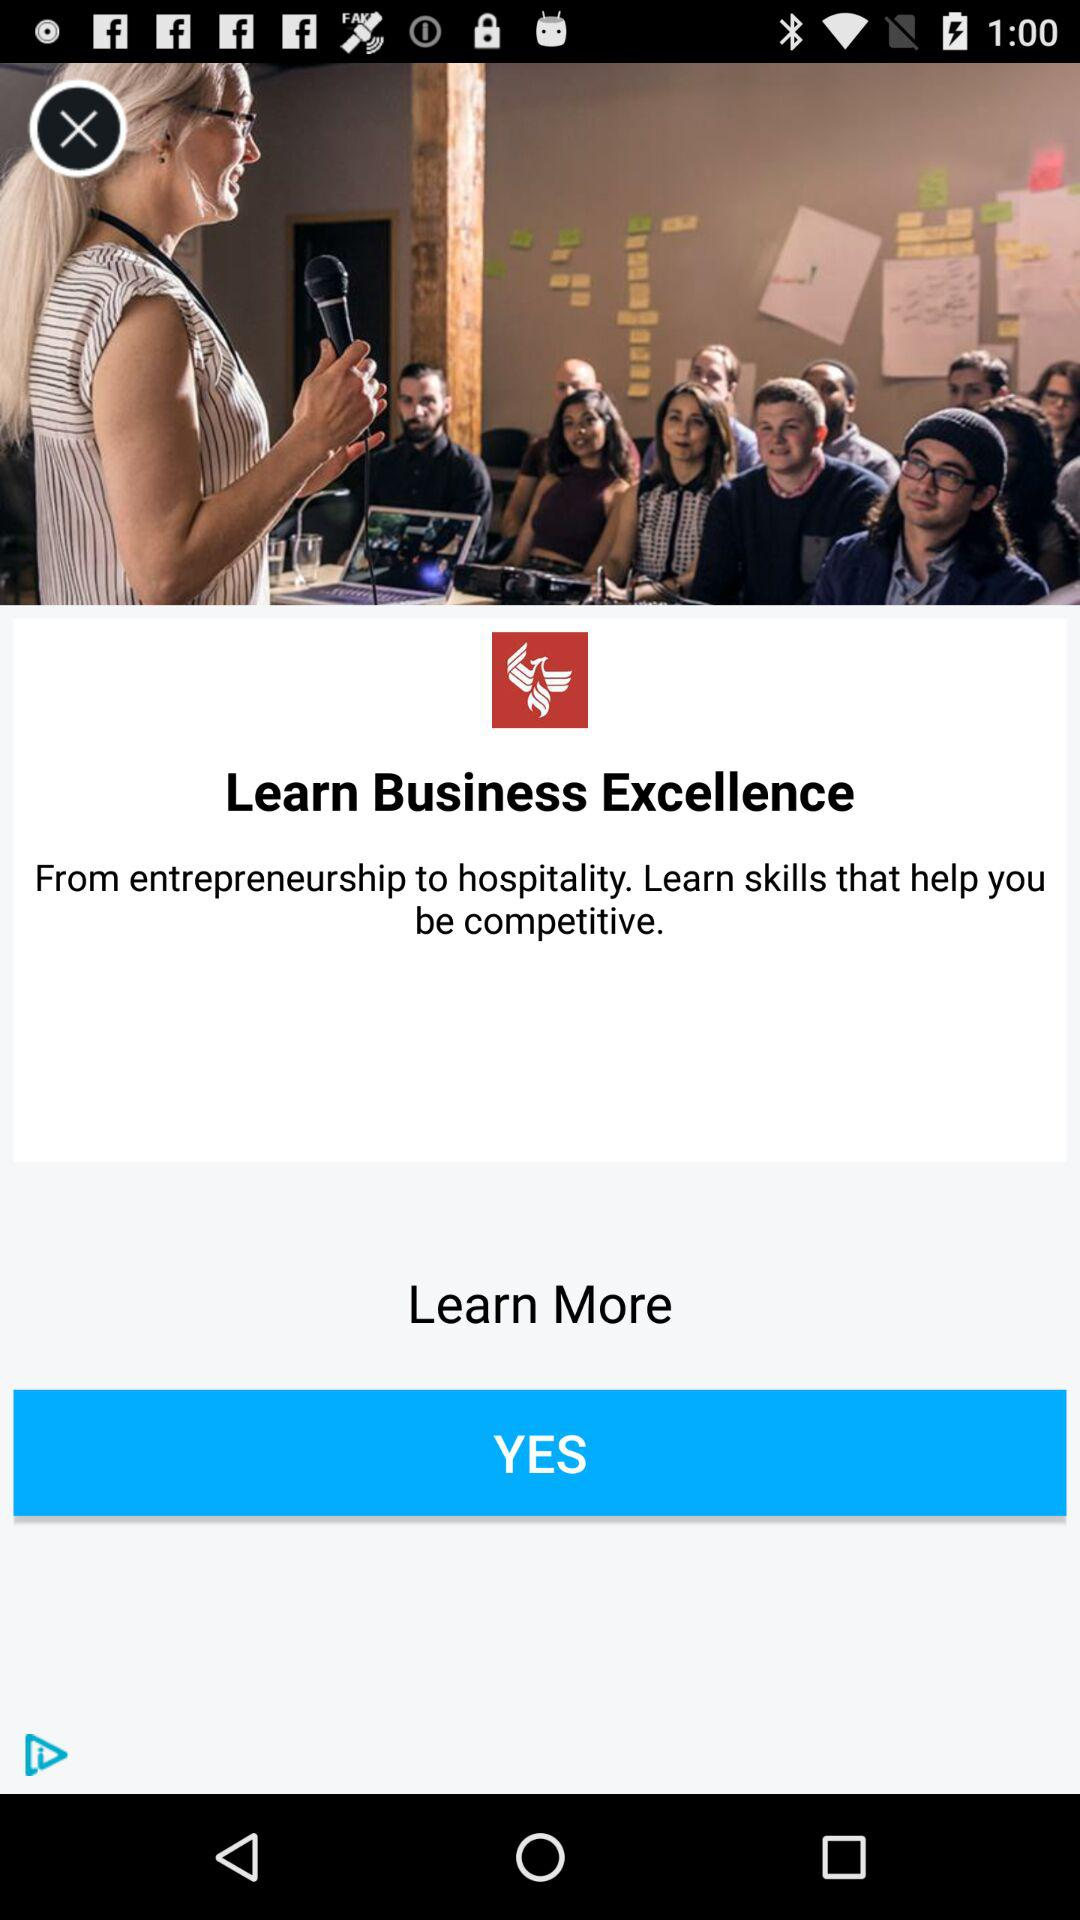What is the application name? The name of the application is "Learn Business Excellence". 